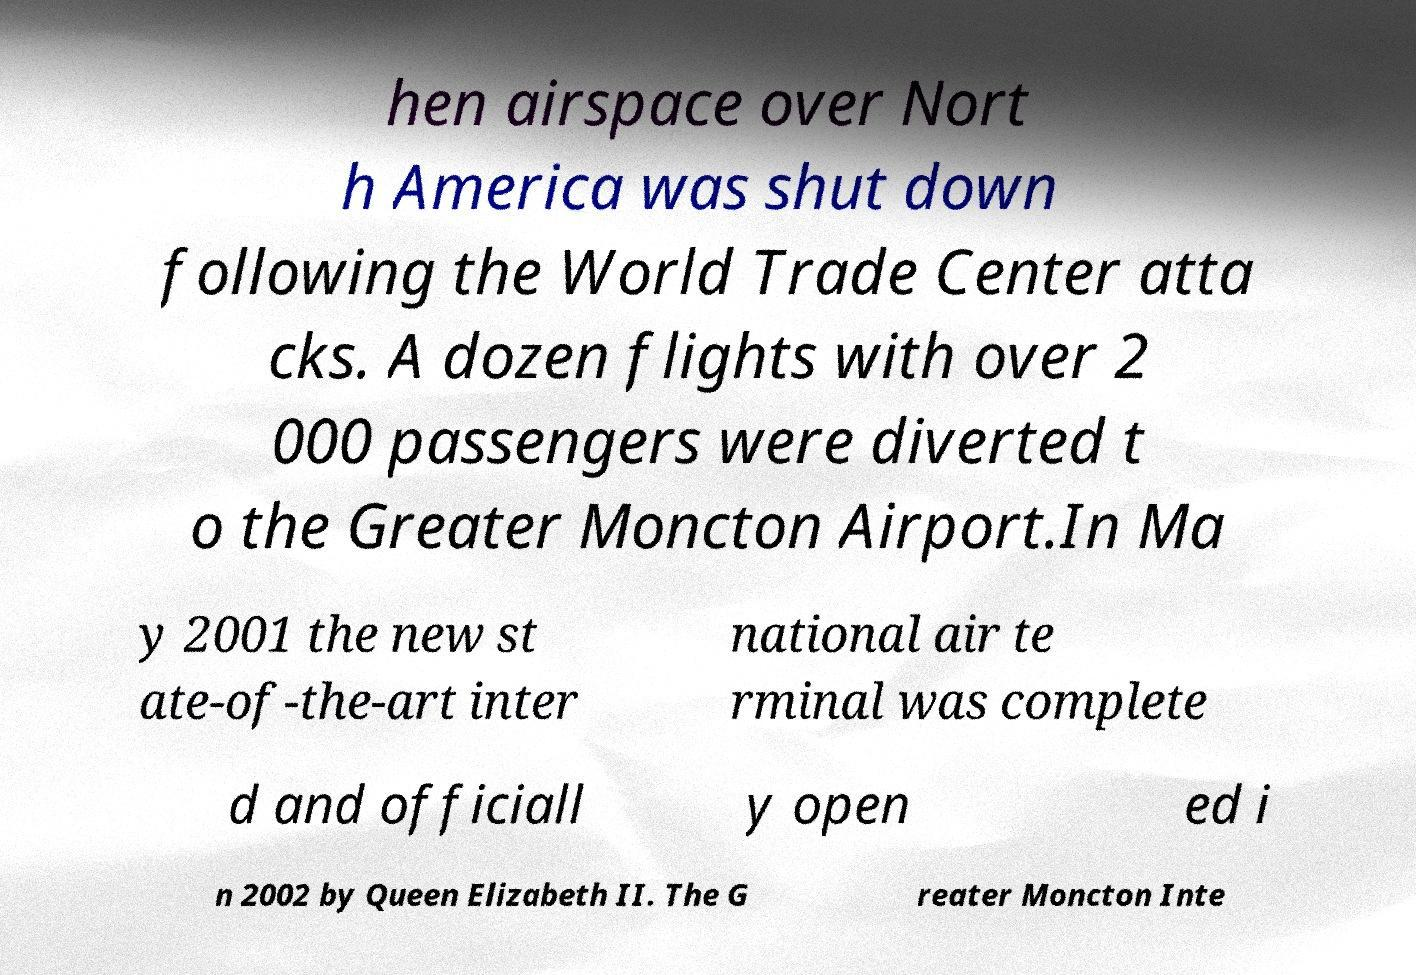I need the written content from this picture converted into text. Can you do that? hen airspace over Nort h America was shut down following the World Trade Center atta cks. A dozen flights with over 2 000 passengers were diverted t o the Greater Moncton Airport.In Ma y 2001 the new st ate-of-the-art inter national air te rminal was complete d and officiall y open ed i n 2002 by Queen Elizabeth II. The G reater Moncton Inte 